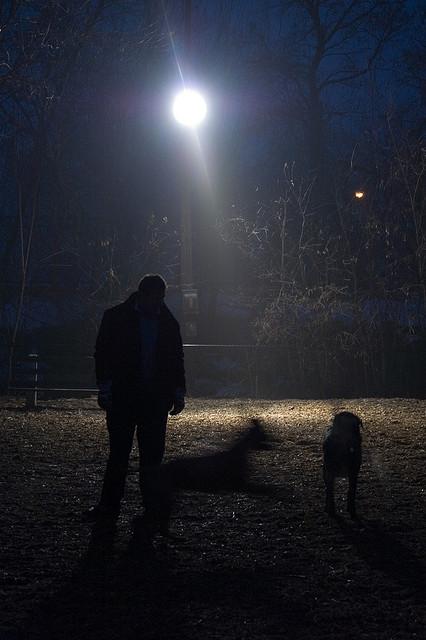What color is the ground?
Concise answer only. Brown. What type of dog is this?
Write a very short answer. Lab. Is the patch of light illuminating the animals from the photographer's perspective?
Quick response, please. No. What is bright in the background?
Quick response, please. Light. What is this man watching?
Write a very short answer. Dogs. Is the snow done falling?
Keep it brief. Yes. Is there water?
Be succinct. No. 